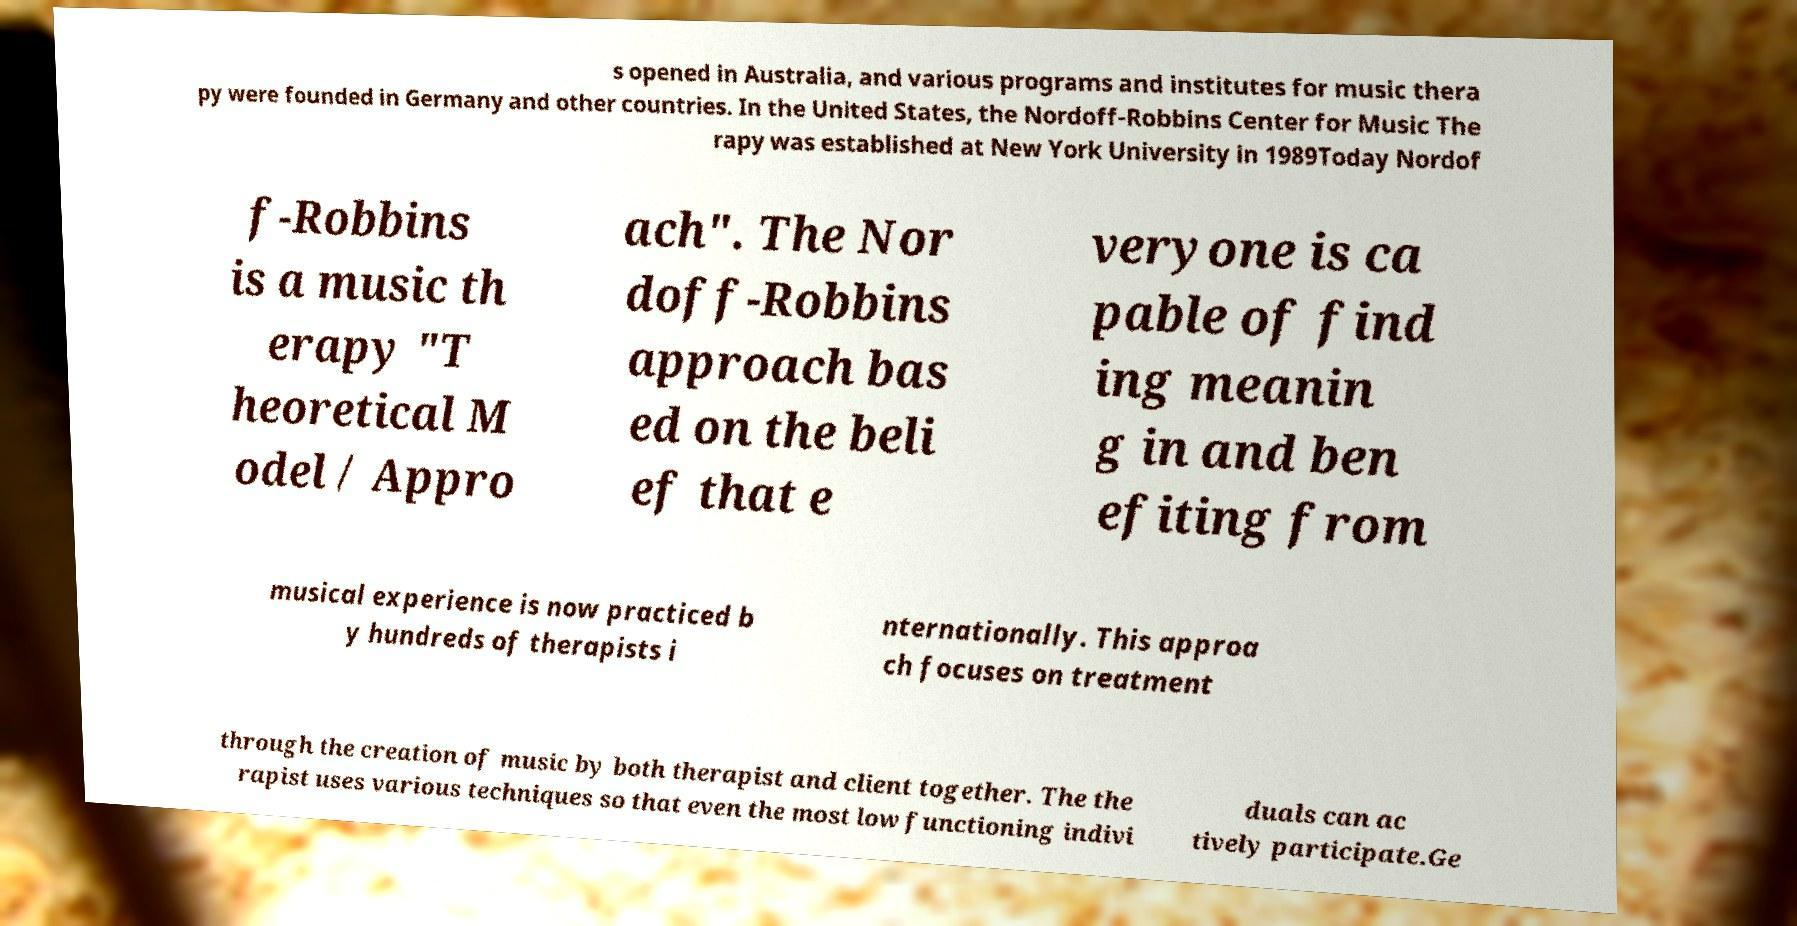Could you assist in decoding the text presented in this image and type it out clearly? s opened in Australia, and various programs and institutes for music thera py were founded in Germany and other countries. In the United States, the Nordoff-Robbins Center for Music The rapy was established at New York University in 1989Today Nordof f-Robbins is a music th erapy "T heoretical M odel / Appro ach". The Nor doff-Robbins approach bas ed on the beli ef that e veryone is ca pable of find ing meanin g in and ben efiting from musical experience is now practiced b y hundreds of therapists i nternationally. This approa ch focuses on treatment through the creation of music by both therapist and client together. The the rapist uses various techniques so that even the most low functioning indivi duals can ac tively participate.Ge 